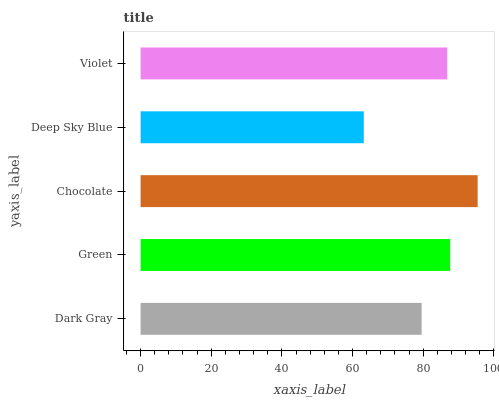Is Deep Sky Blue the minimum?
Answer yes or no. Yes. Is Chocolate the maximum?
Answer yes or no. Yes. Is Green the minimum?
Answer yes or no. No. Is Green the maximum?
Answer yes or no. No. Is Green greater than Dark Gray?
Answer yes or no. Yes. Is Dark Gray less than Green?
Answer yes or no. Yes. Is Dark Gray greater than Green?
Answer yes or no. No. Is Green less than Dark Gray?
Answer yes or no. No. Is Violet the high median?
Answer yes or no. Yes. Is Violet the low median?
Answer yes or no. Yes. Is Dark Gray the high median?
Answer yes or no. No. Is Chocolate the low median?
Answer yes or no. No. 